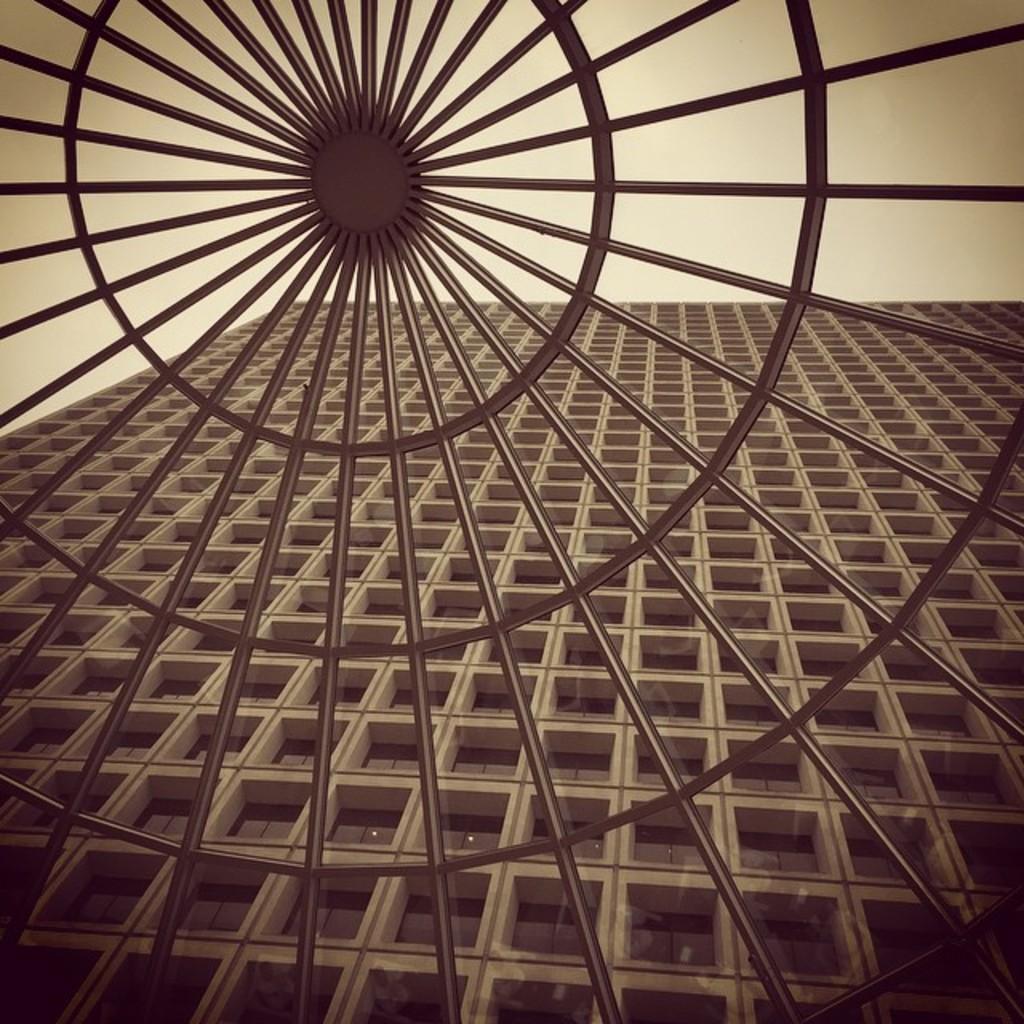In one or two sentences, can you explain what this image depicts? In this image I can see a wheel like metal structure through which I can see a multistory building and the sky at the top of the image. 